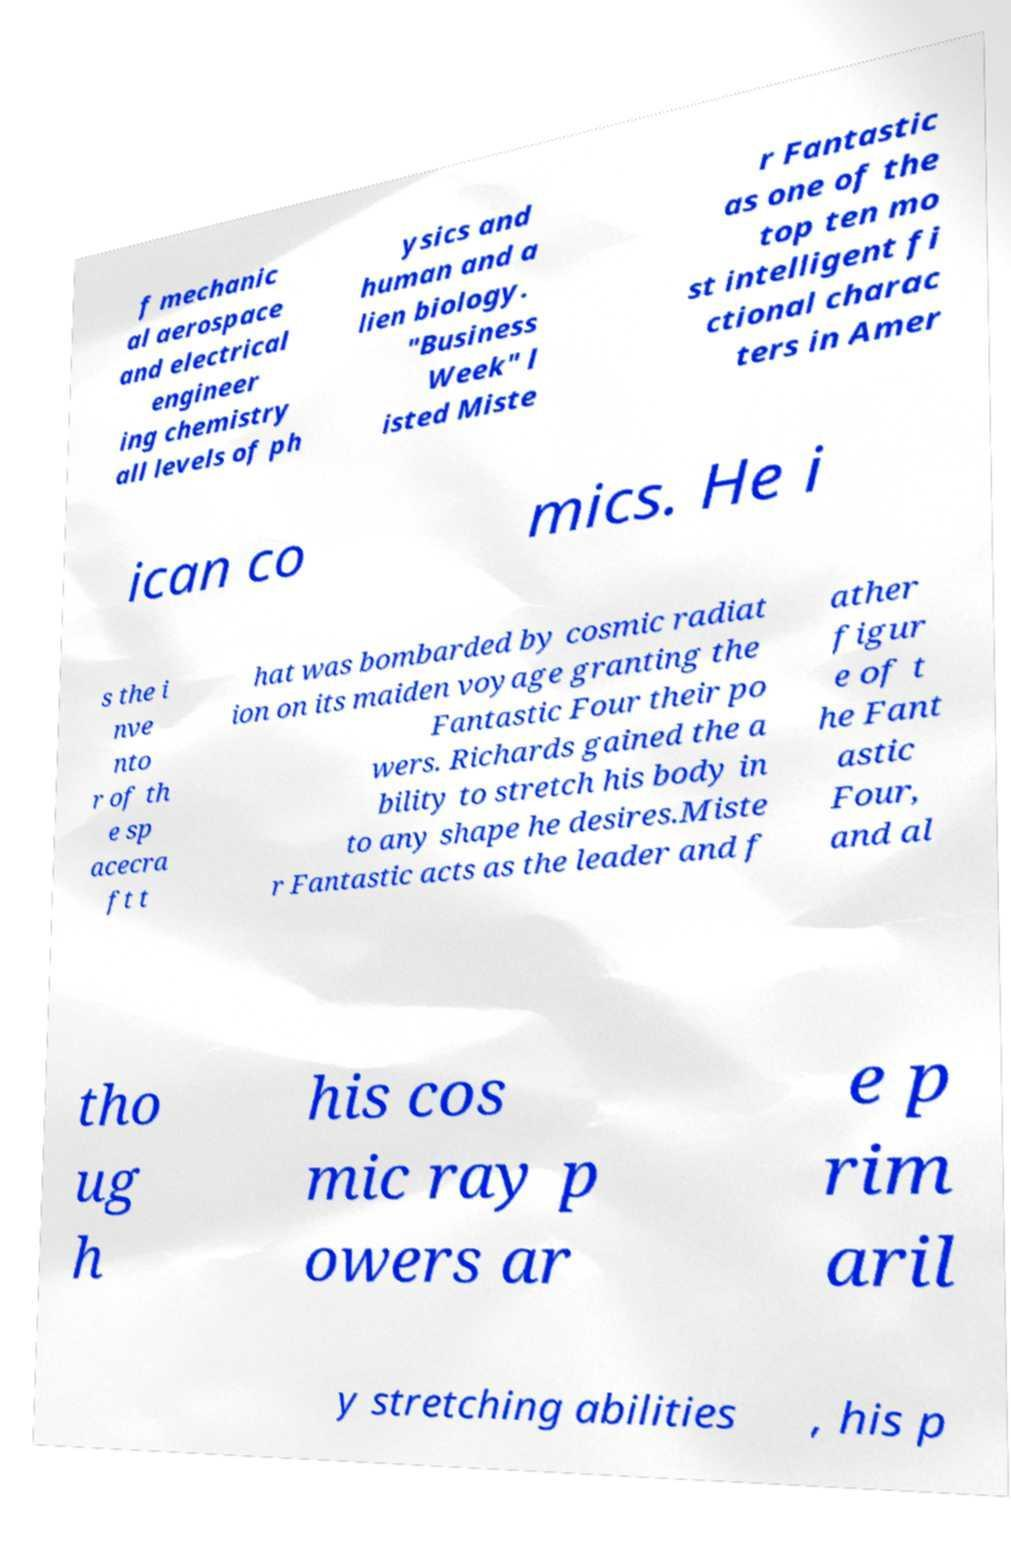Please read and relay the text visible in this image. What does it say? f mechanic al aerospace and electrical engineer ing chemistry all levels of ph ysics and human and a lien biology. "Business Week" l isted Miste r Fantastic as one of the top ten mo st intelligent fi ctional charac ters in Amer ican co mics. He i s the i nve nto r of th e sp acecra ft t hat was bombarded by cosmic radiat ion on its maiden voyage granting the Fantastic Four their po wers. Richards gained the a bility to stretch his body in to any shape he desires.Miste r Fantastic acts as the leader and f ather figur e of t he Fant astic Four, and al tho ug h his cos mic ray p owers ar e p rim aril y stretching abilities , his p 